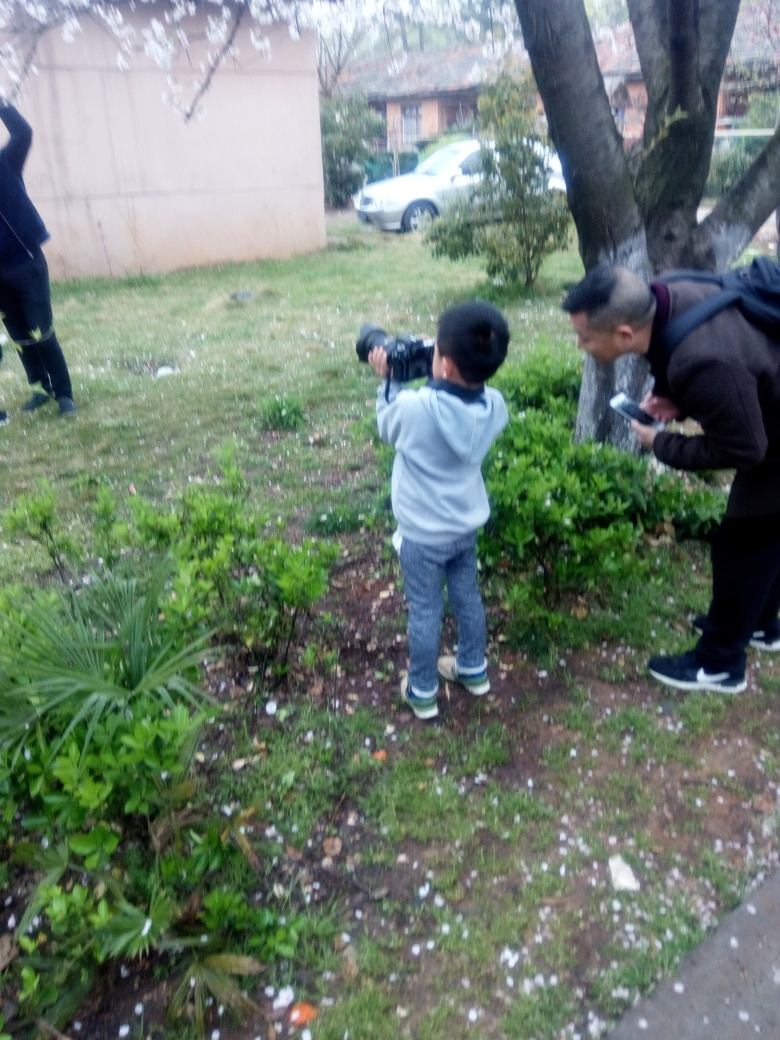How do the main subjects of the image appear?
A. Blurred
B. Sharp
C. Clear While the objects and individuals in the forefront are somewhat out of focus, indicating slight motion or camera shake, the overall scene is reasonably discernible. Thus, the subjects are neither perfectly sharp (B) nor entirely clear (C), but also not significantly blurred (A). A more accurate description would be that they are moderately clear with some areas being slightly blurred. 